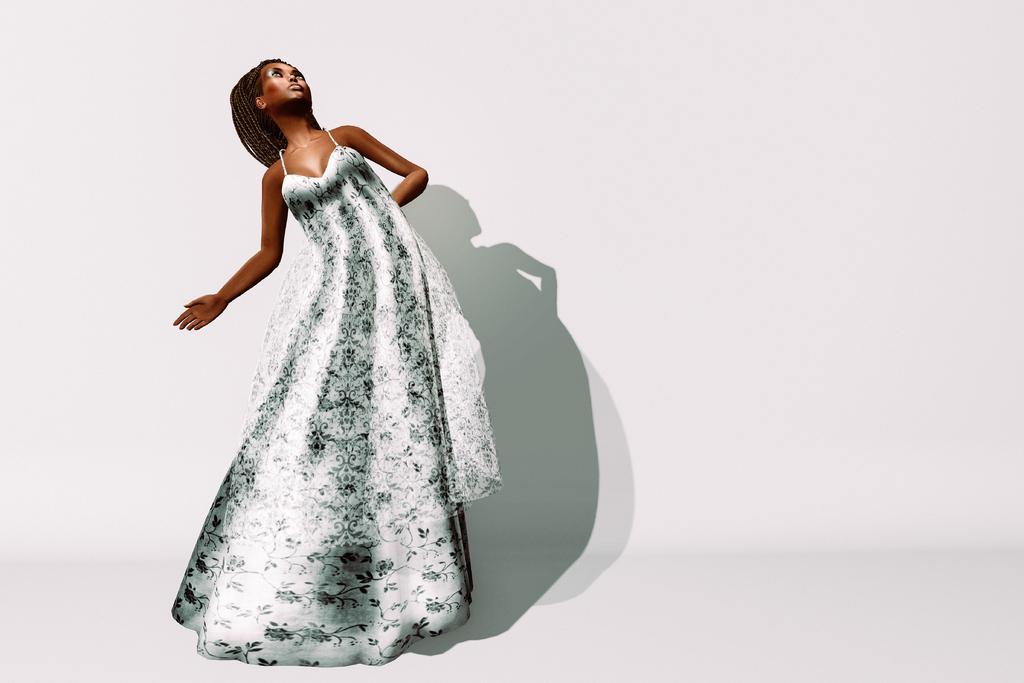In one or two sentences, can you explain what this image depicts? This is an animated image where we can see a woman is standing. In the background we can see shadow on the wall. 